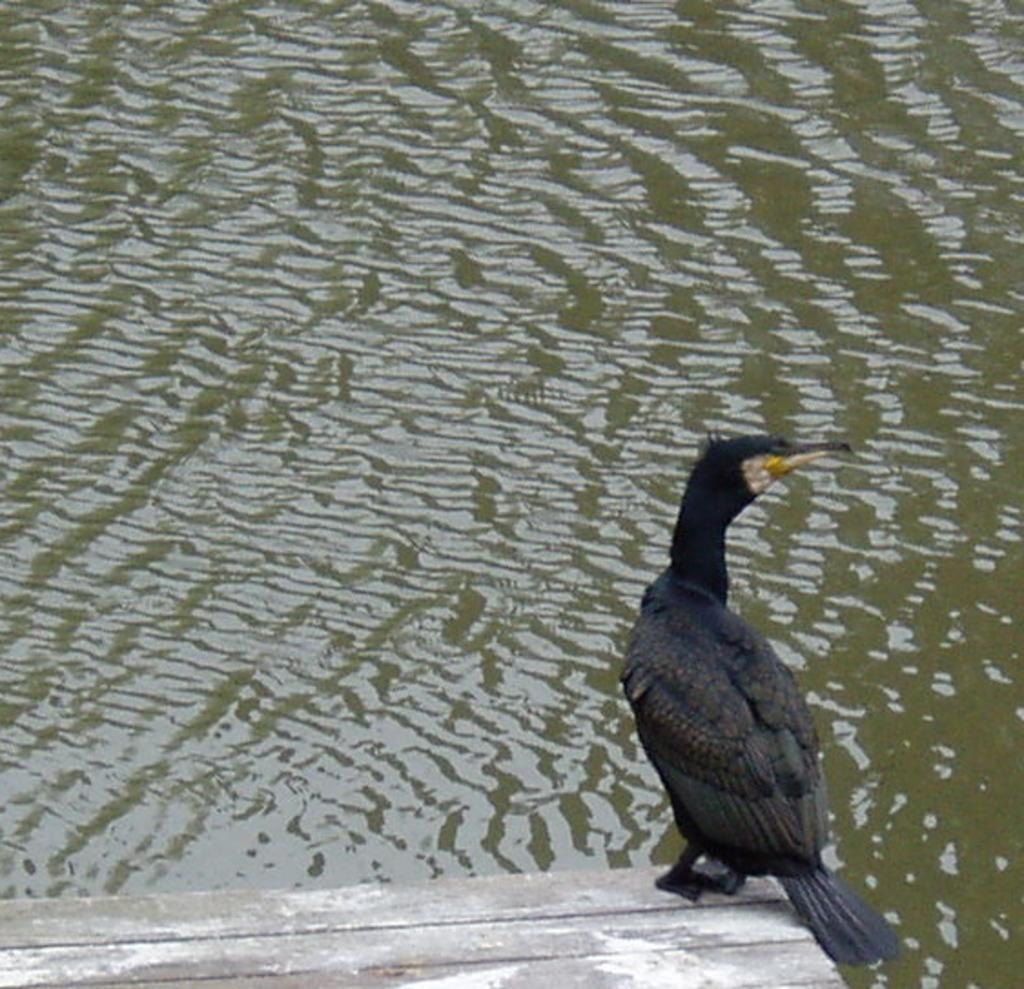What type of bird is in the image? There is a double crested cormorant in the image. Where is the cormorant located? The cormorant is on a dock. What part of the image is the cormorant in? The cormorant is at the bottom side of the image. What can be seen in the background of the image? There is water visible in the image. What type of protest is the cormorant participating in on the dock? There is no protest present in the image, and the cormorant is not participating in any such activity. 